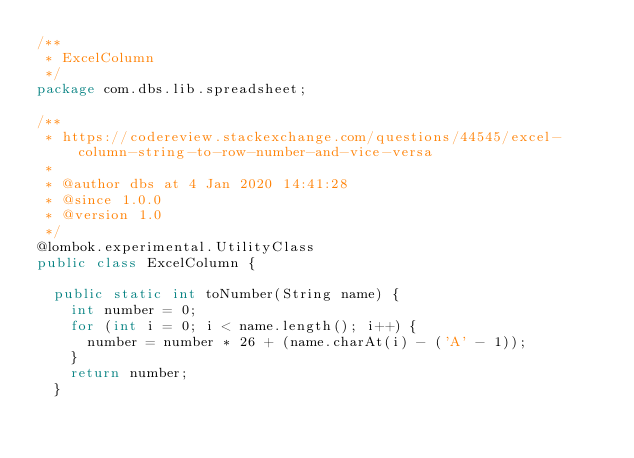Convert code to text. <code><loc_0><loc_0><loc_500><loc_500><_Java_>/**
 * ExcelColumn
 */
package com.dbs.lib.spreadsheet;

/**
 * https://codereview.stackexchange.com/questions/44545/excel-column-string-to-row-number-and-vice-versa
 * 
 * @author dbs at 4 Jan 2020 14:41:28
 * @since 1.0.0
 * @version 1.0
 */
@lombok.experimental.UtilityClass
public class ExcelColumn {

  public static int toNumber(String name) {
    int number = 0;
    for (int i = 0; i < name.length(); i++) {
      number = number * 26 + (name.charAt(i) - ('A' - 1));
    }
    return number;
  }
</code> 